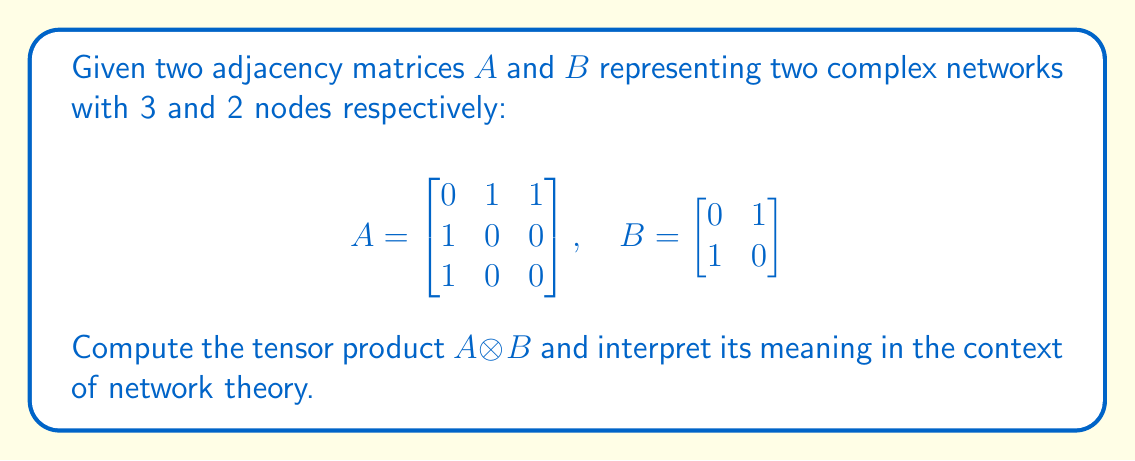Can you answer this question? To compute the tensor product $A \otimes B$, we follow these steps:

1) The tensor product of two matrices results in a block matrix where each element of $A$ is multiplied by the entire matrix $B$. The resulting matrix will have dimensions $(3 \times 3) \times (2 \times 2) = 6 \times 6$.

2) We compute each block:

   For $a_{11} = 0$: $0 \cdot B = \begin{bmatrix} 0 & 0 \\ 0 & 0 \end{bmatrix}$
   
   For $a_{12} = 1$: $1 \cdot B = \begin{bmatrix} 0 & 1 \\ 1 & 0 \end{bmatrix}$
   
   For $a_{13} = 1$: $1 \cdot B = \begin{bmatrix} 0 & 1 \\ 1 & 0 \end{bmatrix}$
   
   For $a_{21} = 1$: $1 \cdot B = \begin{bmatrix} 0 & 1 \\ 1 & 0 \end{bmatrix}$
   
   For $a_{22} = 0$: $0 \cdot B = \begin{bmatrix} 0 & 0 \\ 0 & 0 \end{bmatrix}$
   
   For $a_{23} = 0$: $0 \cdot B = \begin{bmatrix} 0 & 0 \\ 0 & 0 \end{bmatrix}$
   
   For $a_{31} = 1$: $1 \cdot B = \begin{bmatrix} 0 & 1 \\ 1 & 0 \end{bmatrix}$
   
   For $a_{32} = 0$: $0 \cdot B = \begin{bmatrix} 0 & 0 \\ 0 & 0 \end{bmatrix}$
   
   For $a_{33} = 0$: $0 \cdot B = \begin{bmatrix} 0 & 0 \\ 0 & 0 \end{bmatrix}$

3) Arranging these blocks, we get:

$$A \otimes B = \begin{bmatrix}
0 & 0 & 0 & 1 & 0 & 1 \\
0 & 0 & 1 & 0 & 1 & 0 \\
0 & 1 & 0 & 0 & 0 & 0 \\
1 & 0 & 0 & 0 & 0 & 0 \\
0 & 1 & 0 & 0 & 0 & 0 \\
1 & 0 & 0 & 0 & 0 & 0
\end{bmatrix}$$

4) Interpretation: The resulting matrix $A \otimes B$ represents the adjacency matrix of a new network that combines the structure of both input networks. This new network has $3 \times 2 = 6$ nodes, where each node in $A$ is replaced by a copy of the entire network $B$. The connections in this new network preserve the structure of both original networks.
Answer: $$A \otimes B = \begin{bmatrix}
0 & 0 & 0 & 1 & 0 & 1 \\
0 & 0 & 1 & 0 & 1 & 0 \\
0 & 1 & 0 & 0 & 0 & 0 \\
1 & 0 & 0 & 0 & 0 & 0 \\
0 & 1 & 0 & 0 & 0 & 0 \\
1 & 0 & 0 & 0 & 0 & 0
\end{bmatrix}$$ 